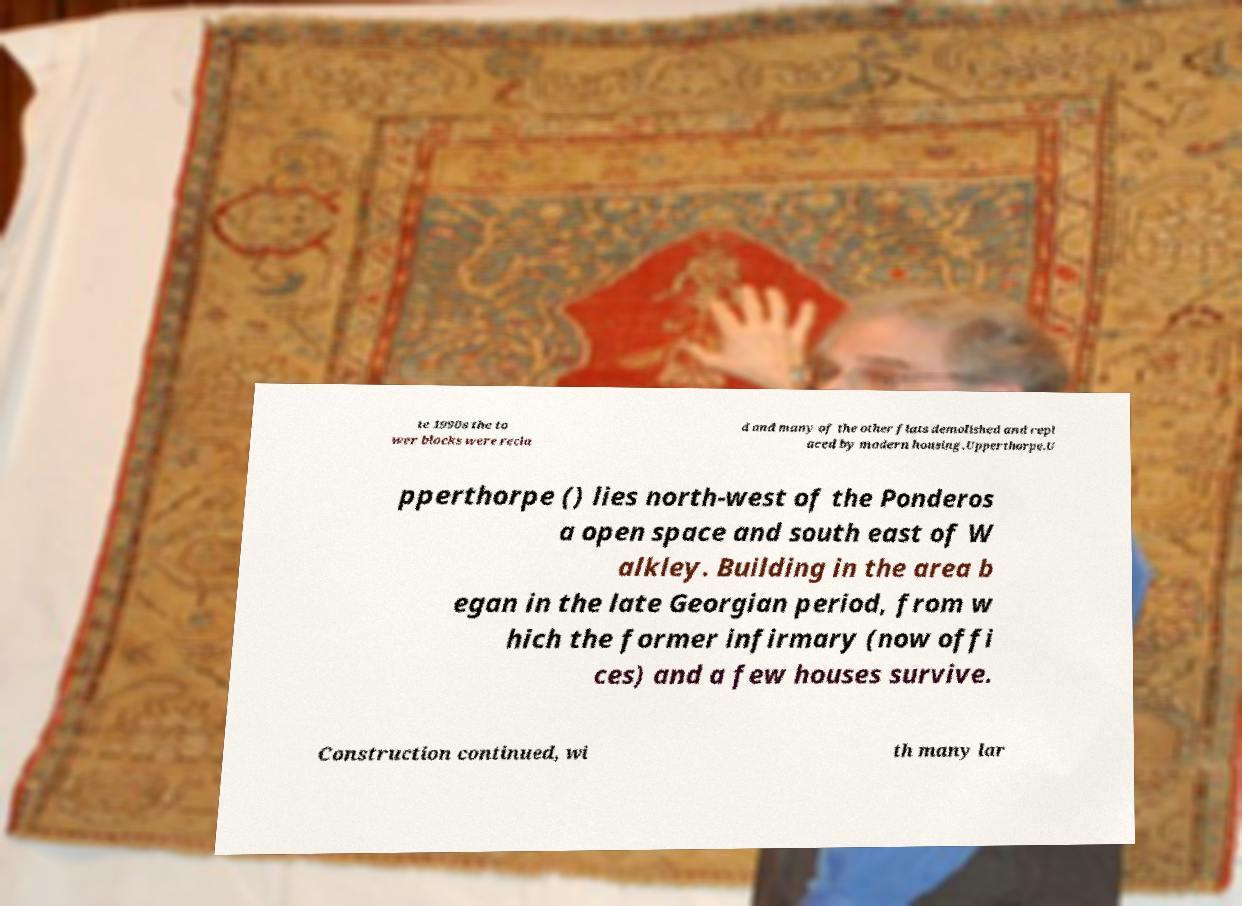For documentation purposes, I need the text within this image transcribed. Could you provide that? te 1990s the to wer blocks were recla d and many of the other flats demolished and repl aced by modern housing.Upperthorpe.U pperthorpe () lies north-west of the Ponderos a open space and south east of W alkley. Building in the area b egan in the late Georgian period, from w hich the former infirmary (now offi ces) and a few houses survive. Construction continued, wi th many lar 